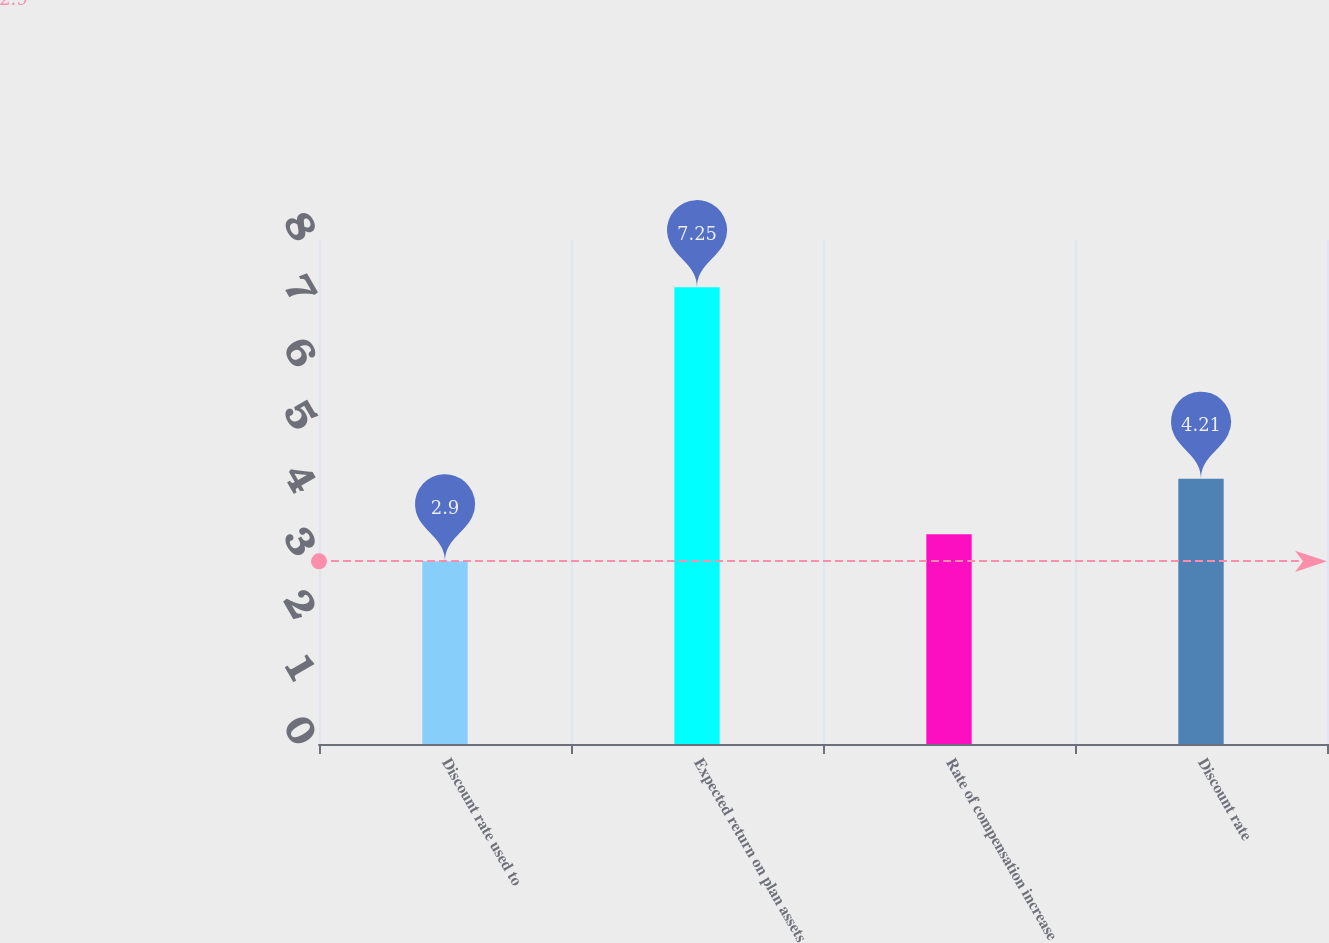Convert chart. <chart><loc_0><loc_0><loc_500><loc_500><bar_chart><fcel>Discount rate used to<fcel>Expected return on plan assets<fcel>Rate of compensation increase<fcel>Discount rate<nl><fcel>2.9<fcel>7.25<fcel>3.33<fcel>4.21<nl></chart> 